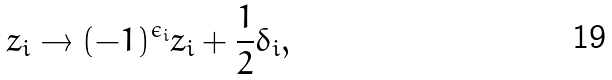<formula> <loc_0><loc_0><loc_500><loc_500>z _ { i } \rightarrow ( - 1 ) ^ { \epsilon _ { i } } z _ { i } + \frac { 1 } { 2 } \delta _ { i } ,</formula> 